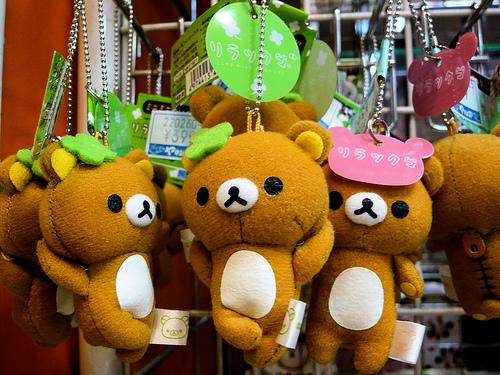Question: where are teddy bears hanging from?
Choices:
A. Ribbons.
B. Christmas tree.
C. Ropes.
D. Chains.
Answer with the letter. Answer: D Question: what color are the chains?
Choices:
A. Silver.
B. Gold.
C. Black.
D. Brown.
Answer with the letter. Answer: A Question: who has black eyes?
Choices:
A. Doll.
B. Porcelain cat.
C. Plastic horse.
D. Stuffed teddy bears.
Answer with the letter. Answer: D Question: why are stuffed animals displayed?
Choices:
A. For a collection.
B. To be sold.
C. In a museum.
D. In 'Lost and Found'.
Answer with the letter. Answer: B Question: what is brown?
Choices:
A. The blanket.
B. The stuffed animals.
C. The wall.
D. The sign.
Answer with the letter. Answer: B 